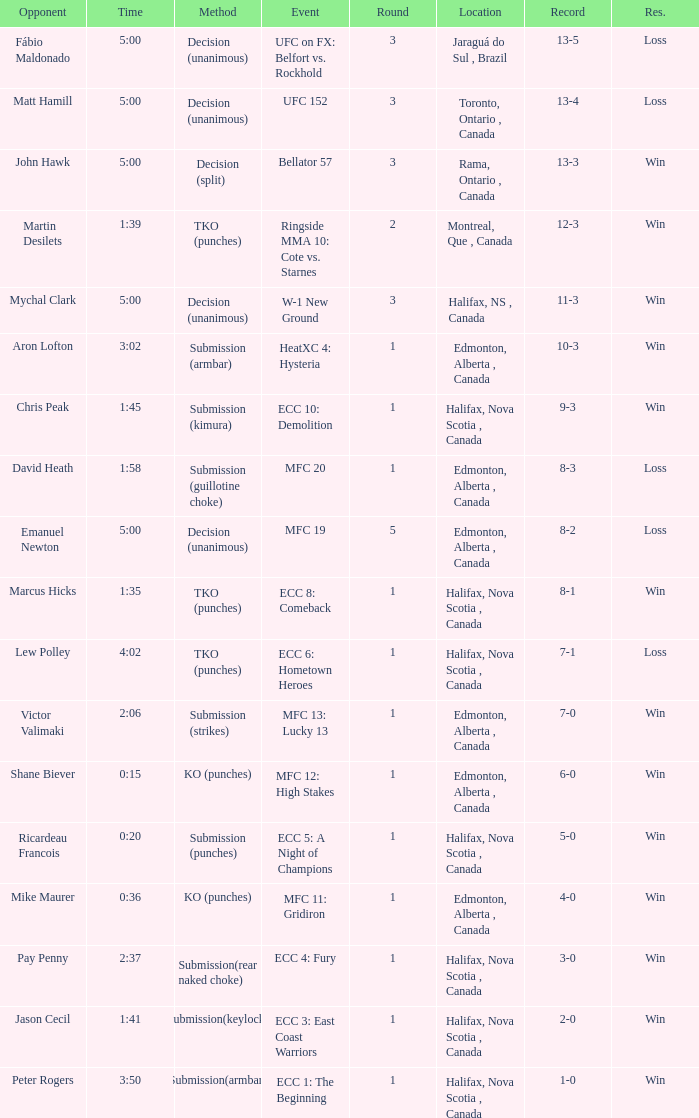Write the full table. {'header': ['Opponent', 'Time', 'Method', 'Event', 'Round', 'Location', 'Record', 'Res.'], 'rows': [['Fábio Maldonado', '5:00', 'Decision (unanimous)', 'UFC on FX: Belfort vs. Rockhold', '3', 'Jaraguá do Sul , Brazil', '13-5', 'Loss'], ['Matt Hamill', '5:00', 'Decision (unanimous)', 'UFC 152', '3', 'Toronto, Ontario , Canada', '13-4', 'Loss'], ['John Hawk', '5:00', 'Decision (split)', 'Bellator 57', '3', 'Rama, Ontario , Canada', '13-3', 'Win'], ['Martin Desilets', '1:39', 'TKO (punches)', 'Ringside MMA 10: Cote vs. Starnes', '2', 'Montreal, Que , Canada', '12-3', 'Win'], ['Mychal Clark', '5:00', 'Decision (unanimous)', 'W-1 New Ground', '3', 'Halifax, NS , Canada', '11-3', 'Win'], ['Aron Lofton', '3:02', 'Submission (armbar)', 'HeatXC 4: Hysteria', '1', 'Edmonton, Alberta , Canada', '10-3', 'Win'], ['Chris Peak', '1:45', 'Submission (kimura)', 'ECC 10: Demolition', '1', 'Halifax, Nova Scotia , Canada', '9-3', 'Win'], ['David Heath', '1:58', 'Submission (guillotine choke)', 'MFC 20', '1', 'Edmonton, Alberta , Canada', '8-3', 'Loss'], ['Emanuel Newton', '5:00', 'Decision (unanimous)', 'MFC 19', '5', 'Edmonton, Alberta , Canada', '8-2', 'Loss'], ['Marcus Hicks', '1:35', 'TKO (punches)', 'ECC 8: Comeback', '1', 'Halifax, Nova Scotia , Canada', '8-1', 'Win'], ['Lew Polley', '4:02', 'TKO (punches)', 'ECC 6: Hometown Heroes', '1', 'Halifax, Nova Scotia , Canada', '7-1', 'Loss'], ['Victor Valimaki', '2:06', 'Submission (strikes)', 'MFC 13: Lucky 13', '1', 'Edmonton, Alberta , Canada', '7-0', 'Win'], ['Shane Biever', '0:15', 'KO (punches)', 'MFC 12: High Stakes', '1', 'Edmonton, Alberta , Canada', '6-0', 'Win'], ['Ricardeau Francois', '0:20', 'Submission (punches)', 'ECC 5: A Night of Champions', '1', 'Halifax, Nova Scotia , Canada', '5-0', 'Win'], ['Mike Maurer', '0:36', 'KO (punches)', 'MFC 11: Gridiron', '1', 'Edmonton, Alberta , Canada', '4-0', 'Win'], ['Pay Penny', '2:37', 'Submission(rear naked choke)', 'ECC 4: Fury', '1', 'Halifax, Nova Scotia , Canada', '3-0', 'Win'], ['Jason Cecil', '1:41', 'Submission(keylock)', 'ECC 3: East Coast Warriors', '1', 'Halifax, Nova Scotia , Canada', '2-0', 'Win'], ['Peter Rogers', '3:50', 'Submission(armbar)', 'ECC 1: The Beginning', '1', 'Halifax, Nova Scotia , Canada', '1-0', 'Win']]} Who is the opponent of the match with a win result and a time of 3:02? Aron Lofton. 